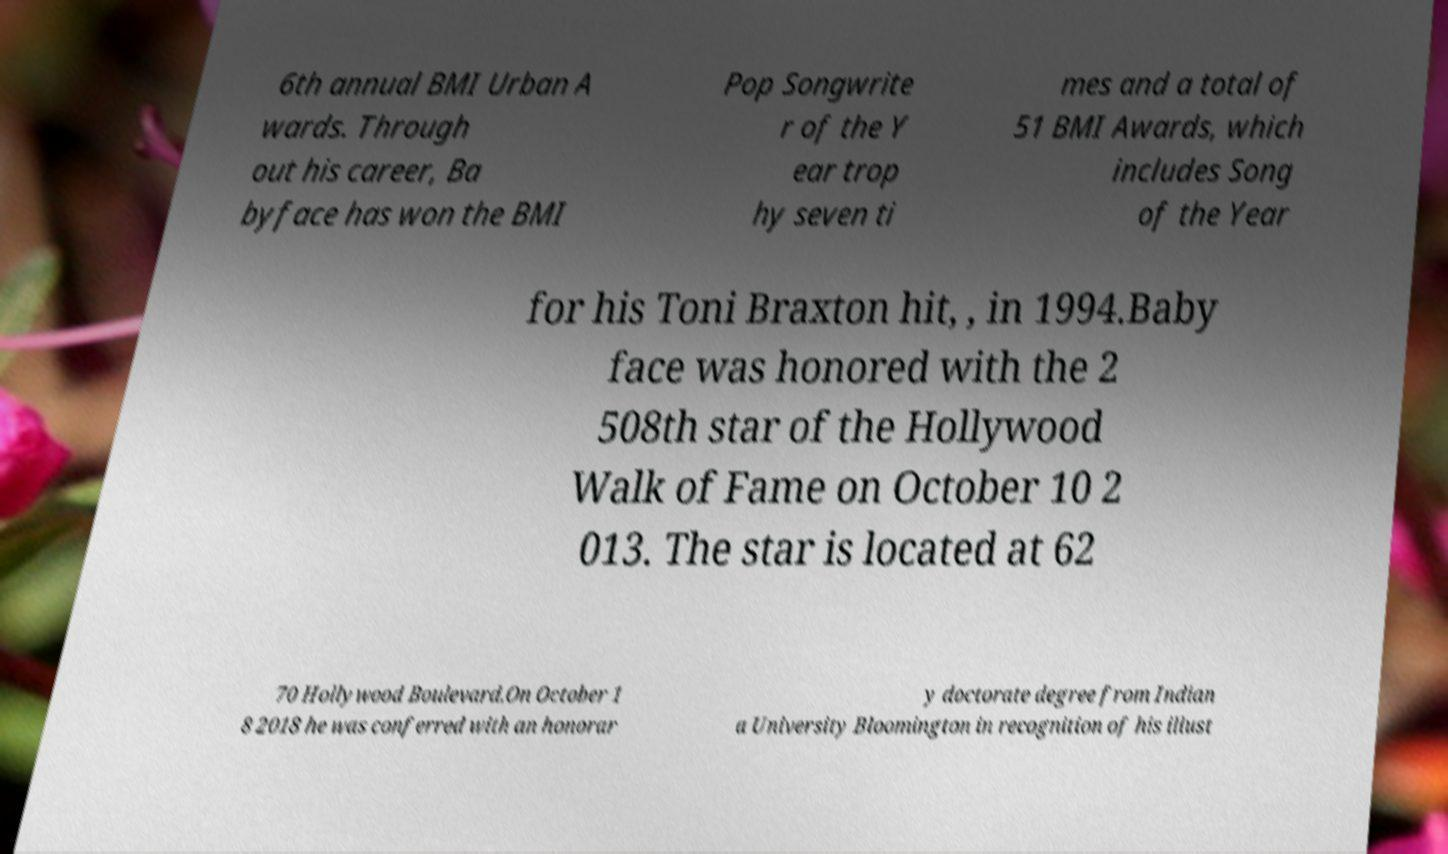Please read and relay the text visible in this image. What does it say? 6th annual BMI Urban A wards. Through out his career, Ba byface has won the BMI Pop Songwrite r of the Y ear trop hy seven ti mes and a total of 51 BMI Awards, which includes Song of the Year for his Toni Braxton hit, , in 1994.Baby face was honored with the 2 508th star of the Hollywood Walk of Fame on October 10 2 013. The star is located at 62 70 Hollywood Boulevard.On October 1 8 2018 he was conferred with an honorar y doctorate degree from Indian a University Bloomington in recognition of his illust 